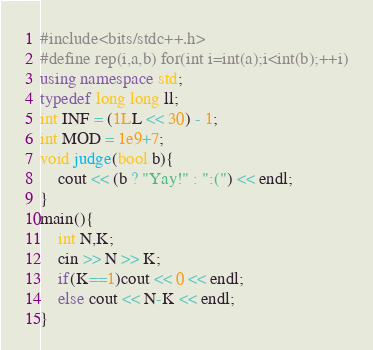Convert code to text. <code><loc_0><loc_0><loc_500><loc_500><_C++_>#include<bits/stdc++.h>
#define rep(i,a,b) for(int i=int(a);i<int(b);++i)
using namespace std;
typedef long long ll;
int INF = (1LL << 30) - 1;
int MOD = 1e9+7;
void judge(bool b){
    cout << (b ? "Yay!" : ":(") << endl;
}
main(){
    int N,K;
    cin >> N >> K;
    if(K==1)cout << 0 << endl;
    else cout << N-K << endl;
}</code> 